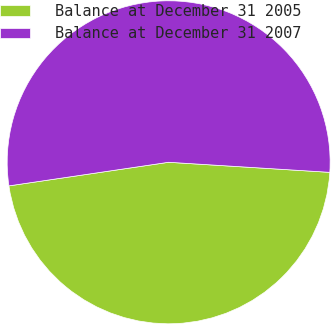Convert chart to OTSL. <chart><loc_0><loc_0><loc_500><loc_500><pie_chart><fcel>Balance at December 31 2005<fcel>Balance at December 31 2007<nl><fcel>46.67%<fcel>53.33%<nl></chart> 